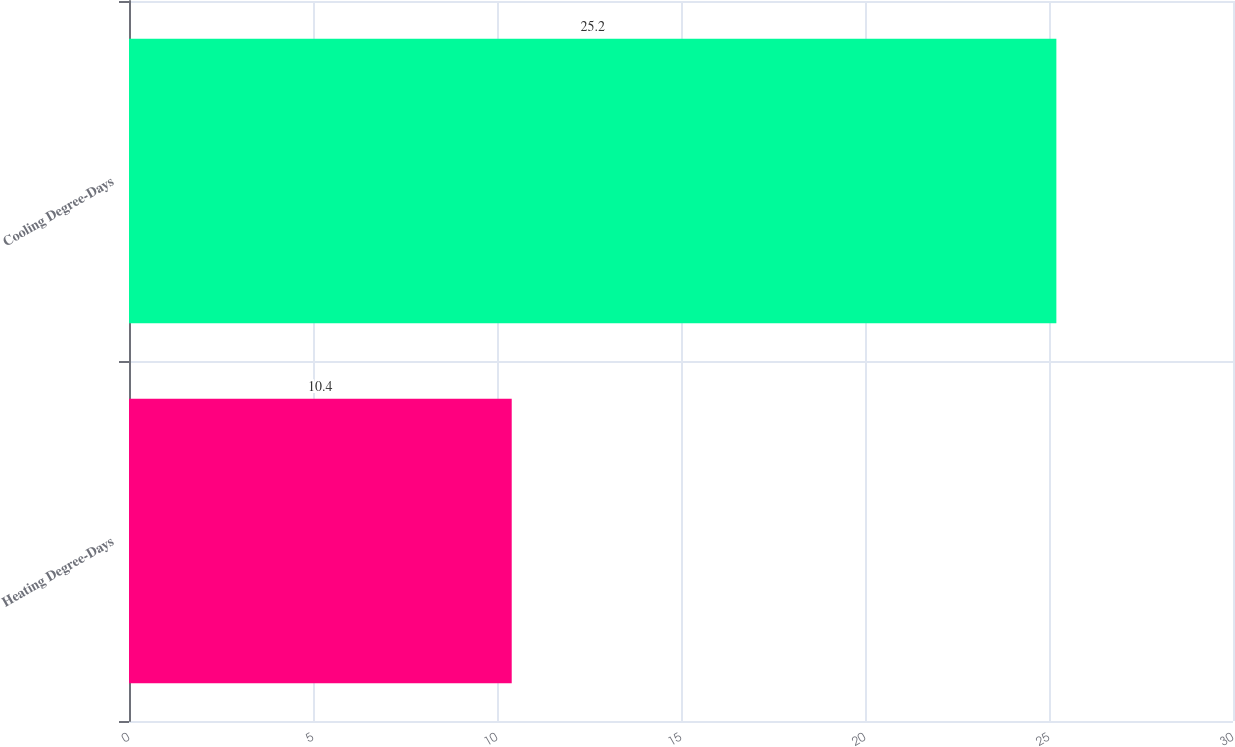<chart> <loc_0><loc_0><loc_500><loc_500><bar_chart><fcel>Heating Degree-Days<fcel>Cooling Degree-Days<nl><fcel>10.4<fcel>25.2<nl></chart> 